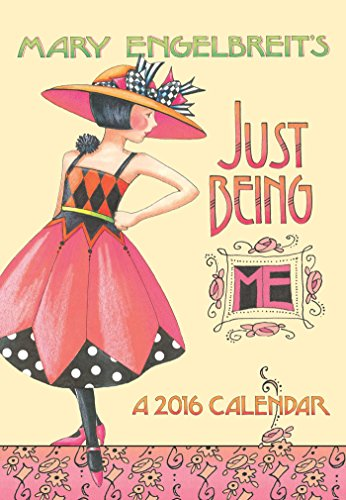What is the title of this book? The complete title of this book is 'Mary Engelbreit 2016 Monthly Pocket Planner: Just Being ME!', which features colorful illustrations alongside calendar pages. 